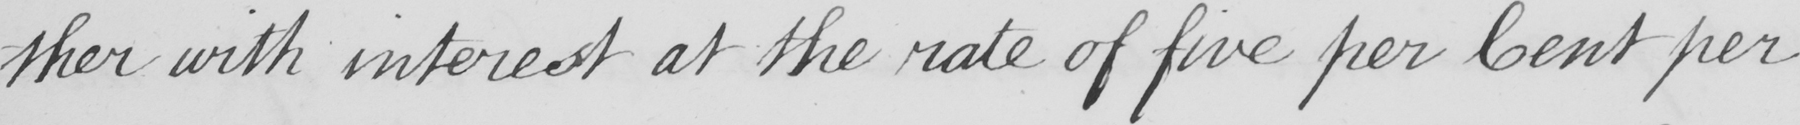What text is written in this handwritten line? -ther with interest at the rate of five per Cent per 